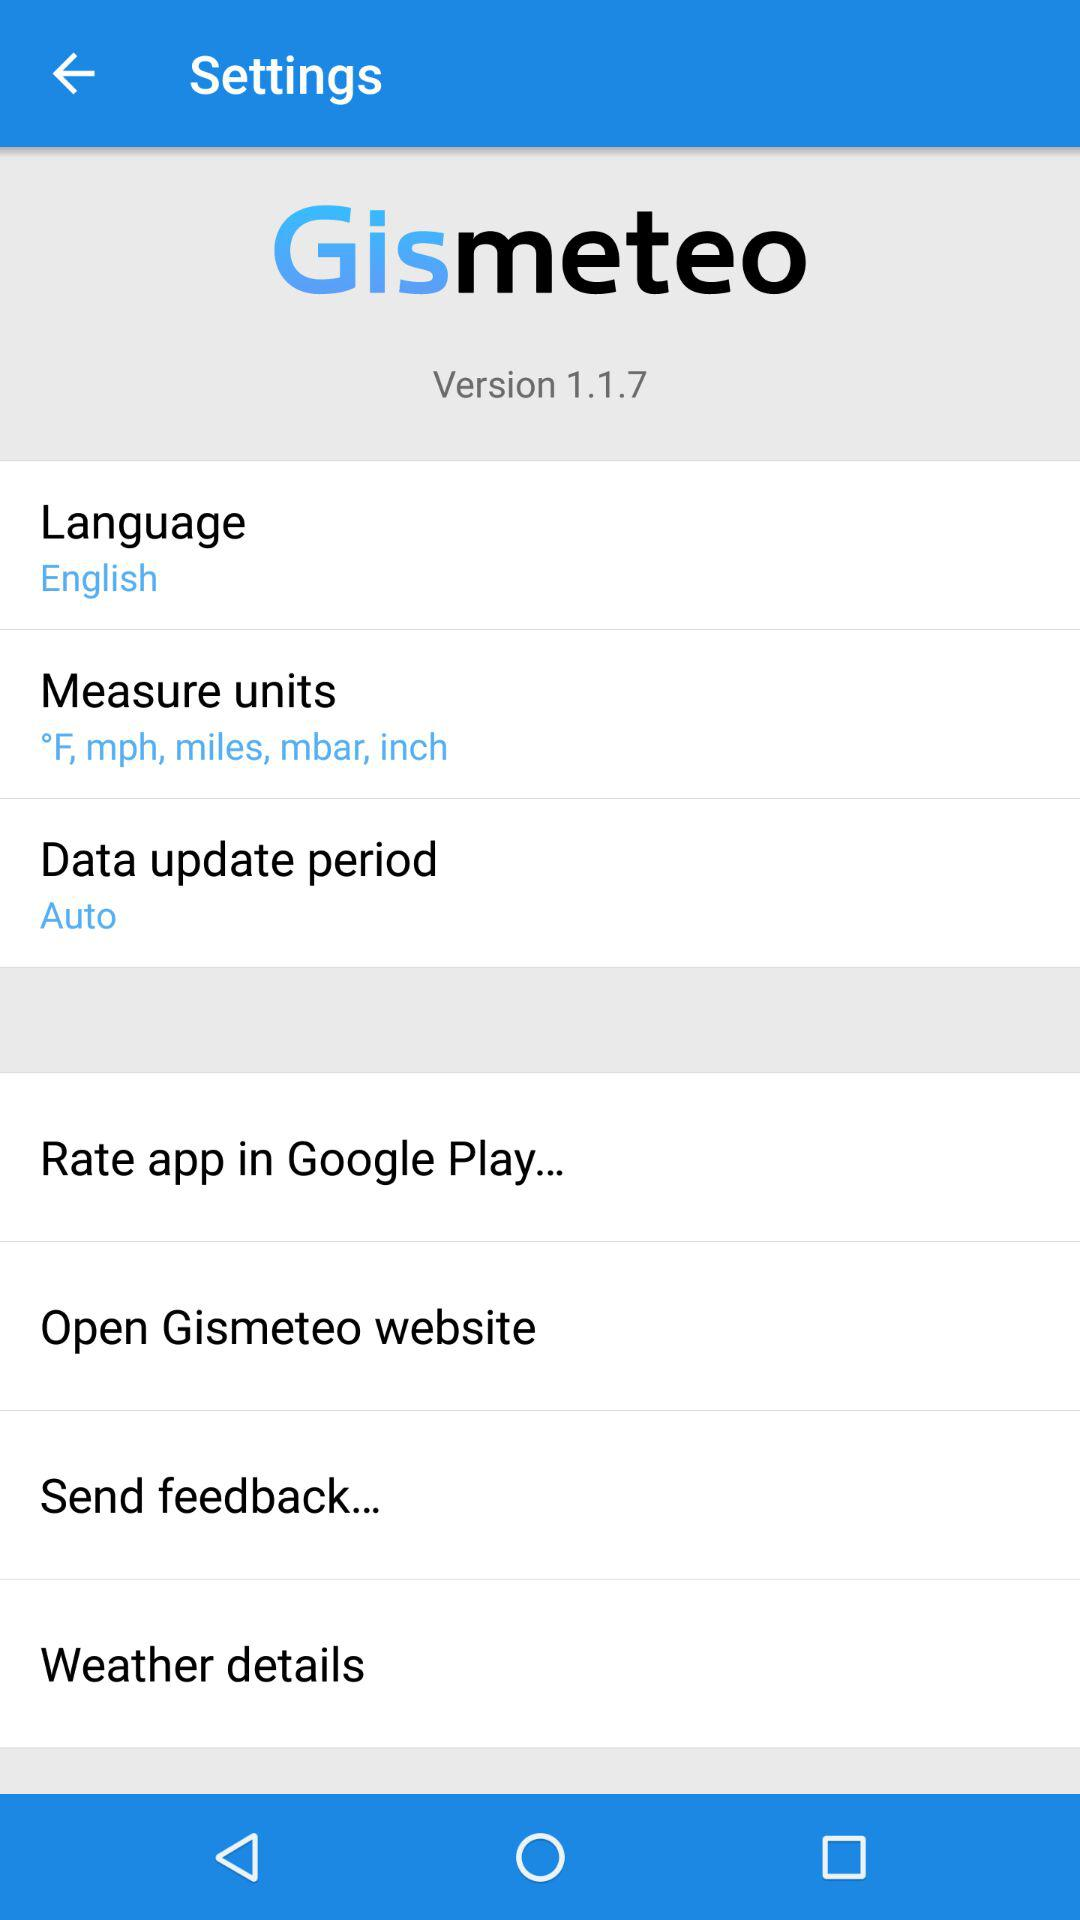What language is mentioned? The mentioned language is English. 